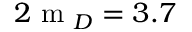<formula> <loc_0><loc_0><loc_500><loc_500>2 m _ { D } = 3 . 7</formula> 